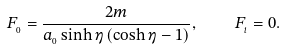Convert formula to latex. <formula><loc_0><loc_0><loc_500><loc_500>F _ { _ { 0 } } = \frac { 2 m } { a _ { _ { 0 } } \sinh \eta \left ( \cosh \eta - 1 \right ) } , \quad F _ { _ { i } } = 0 .</formula> 